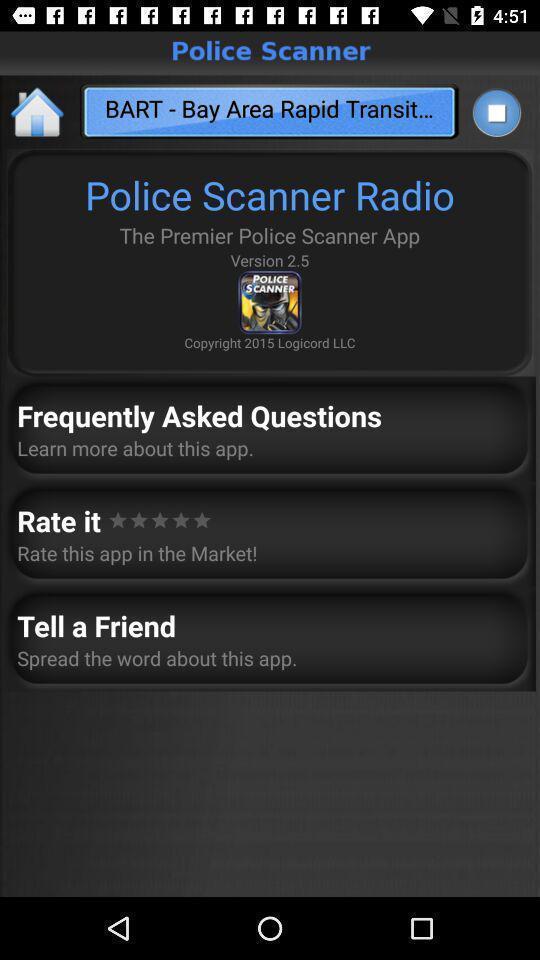Give me a narrative description of this picture. Screen shows multiple options. 